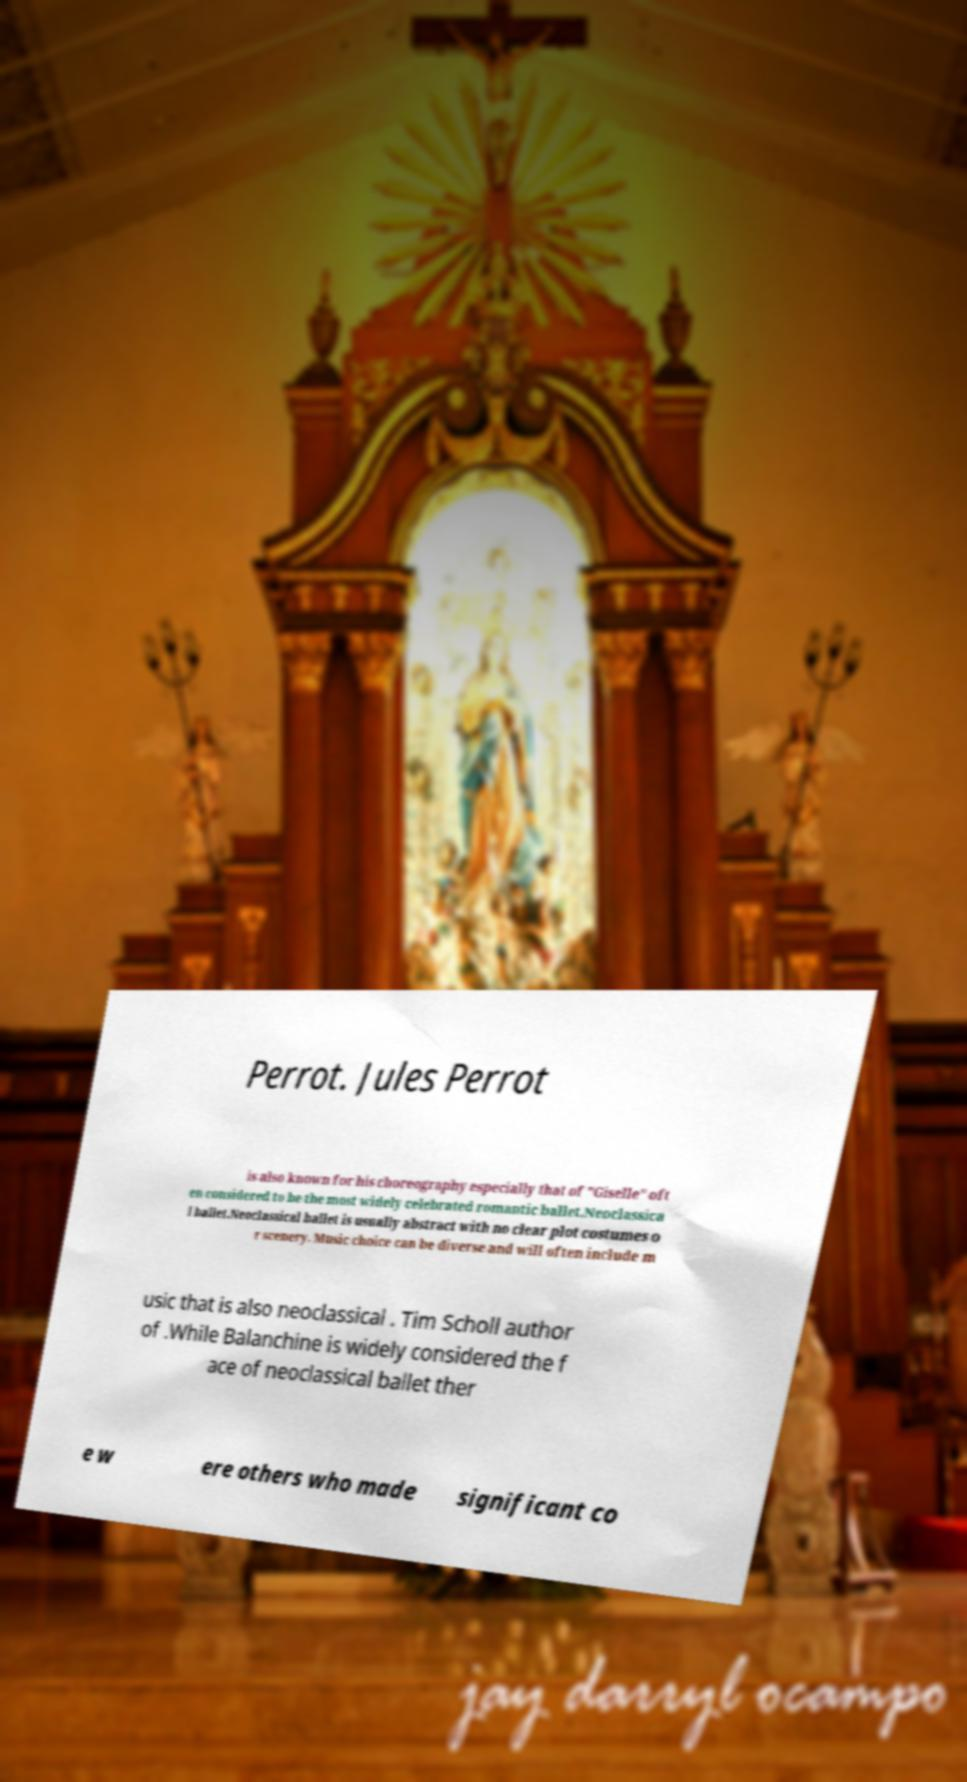Can you accurately transcribe the text from the provided image for me? Perrot. Jules Perrot is also known for his choreography especially that of "Giselle" oft en considered to be the most widely celebrated romantic ballet.Neoclassica l ballet.Neoclassical ballet is usually abstract with no clear plot costumes o r scenery. Music choice can be diverse and will often include m usic that is also neoclassical . Tim Scholl author of .While Balanchine is widely considered the f ace of neoclassical ballet ther e w ere others who made significant co 